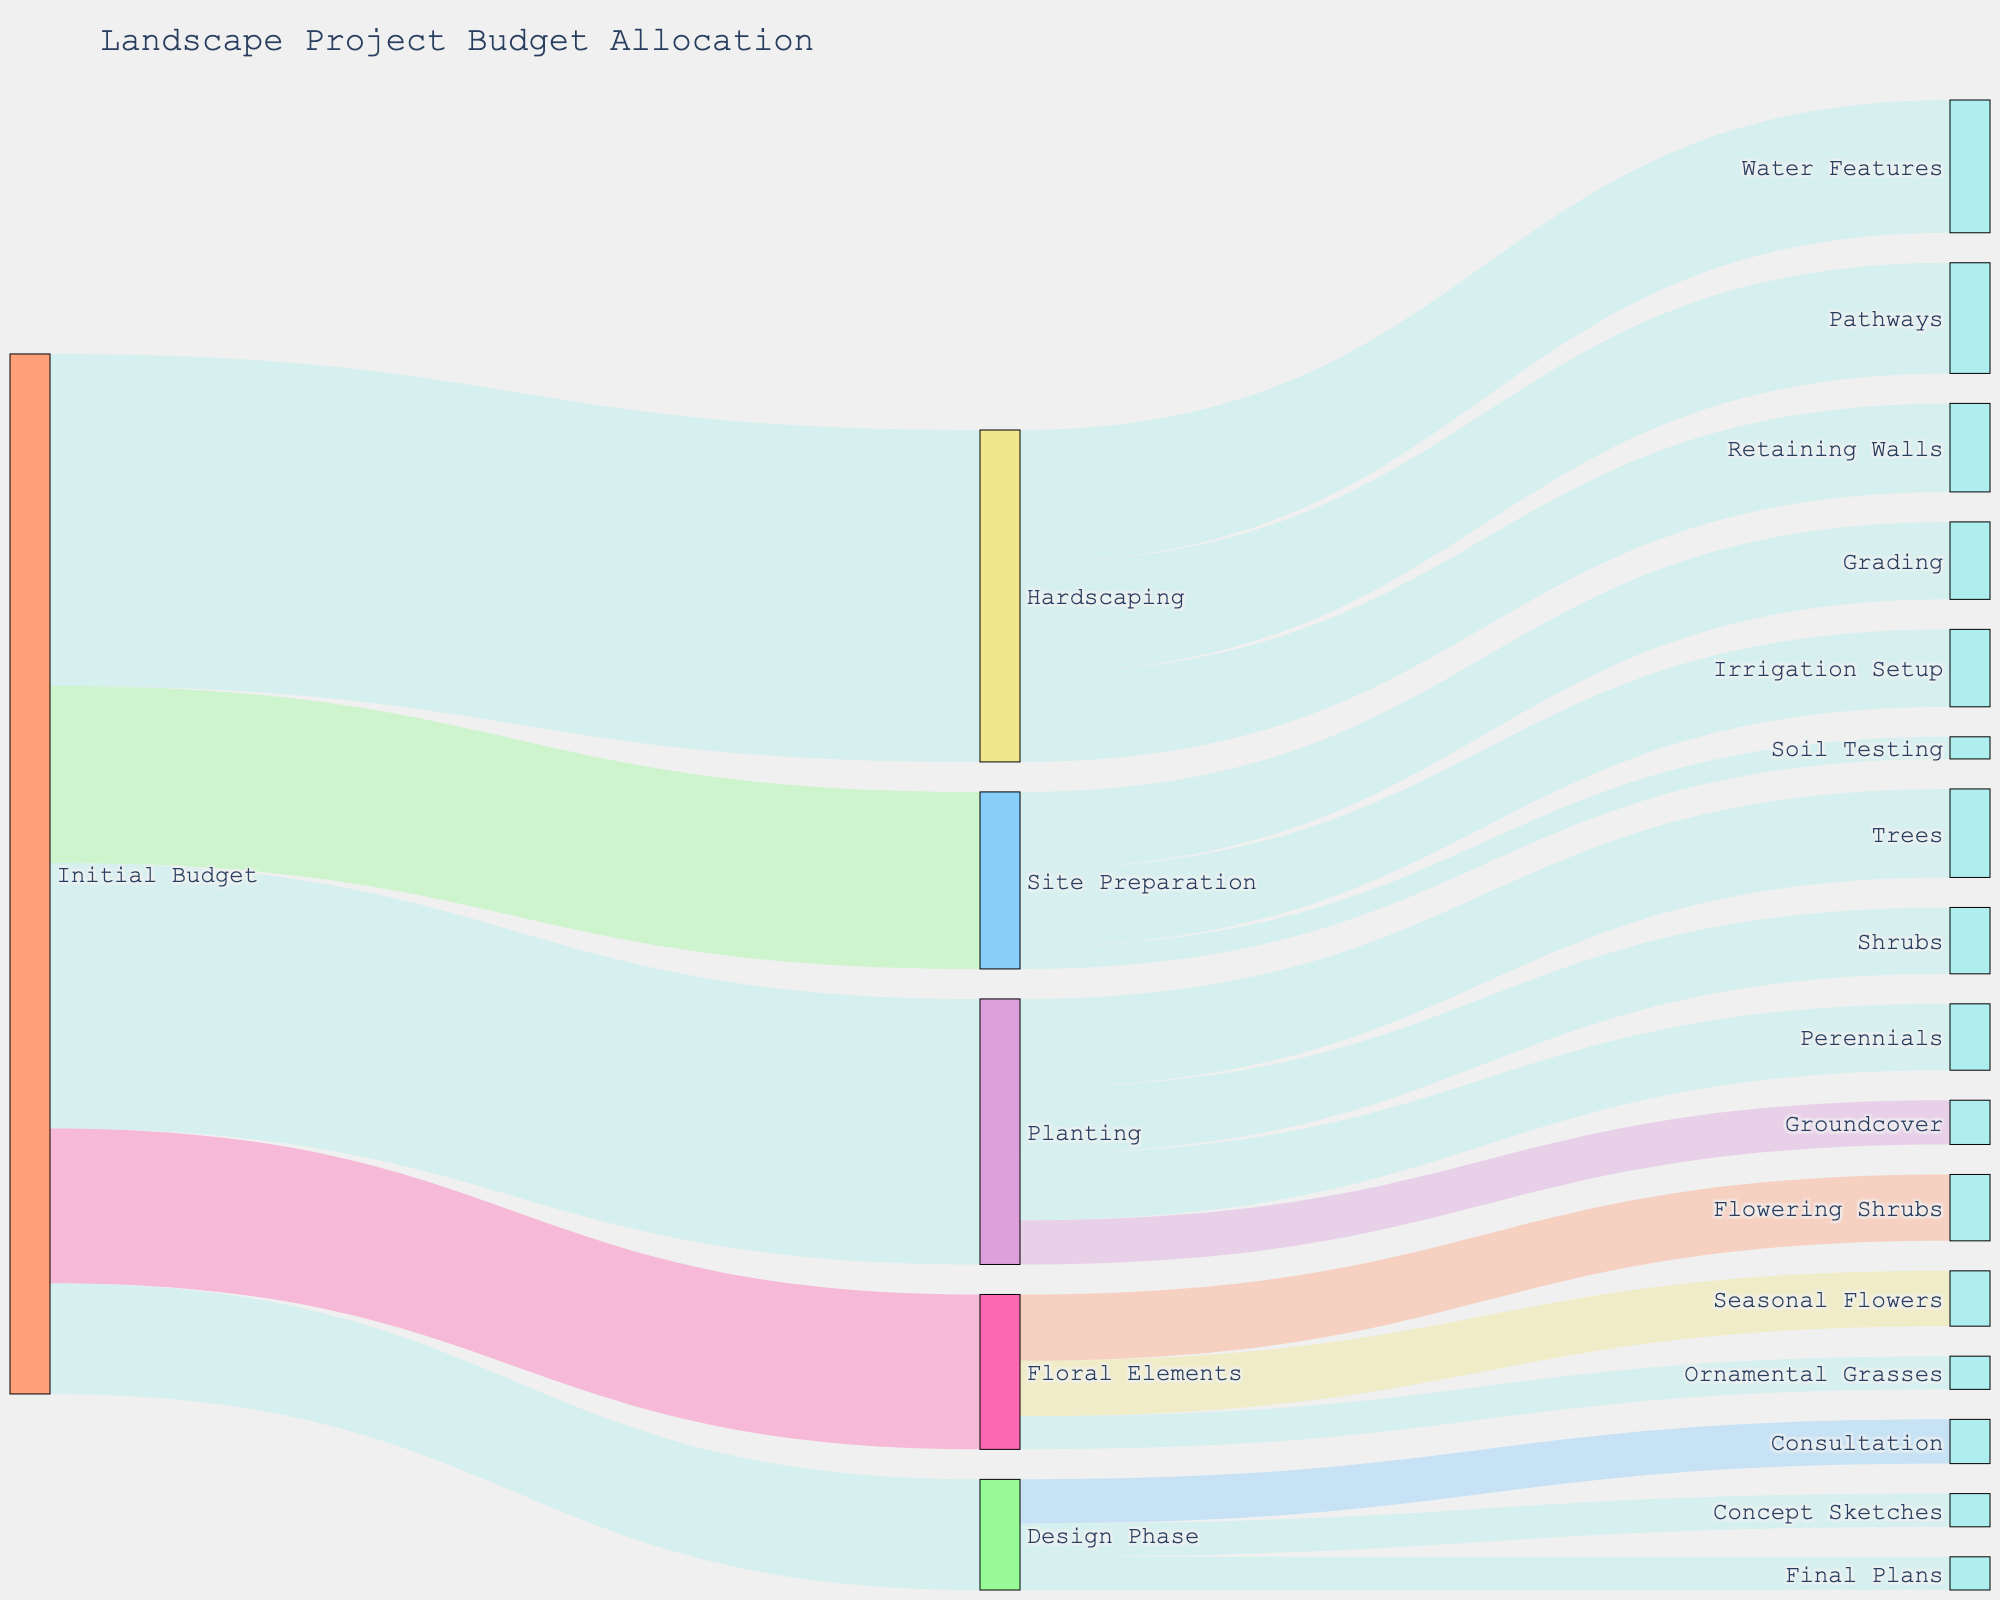what is the main title of the figure? The main title can be found at the top of the figure. It indicates the subject of the visualization.
Answer: Landscape Project Budget Allocation which phase has the highest initial budget allocation? By examining the size of the budget allocations starting from "Initial Budget", the "Hardscaping" phase appears to have the thickest flow, indicating the highest budget.
Answer: Hardscaping how much of the initial budget is allocated to floral elements? Follow the flow from "Initial Budget" to "Floral Elements", where it shows an allocation of 7000.
Answer: 7000 what are the sub-components of the design phase? Trace the flow from "Design Phase" to its three sub-components: "Consultation", "Concept Sketches", and "Final Plans."
Answer: Consultation, Concept Sketches, Final Plans compare the budget allocated to trees with the budget for water features Trace the flow from "Planting" to "Trees" and from "Hardscaping" to "Water Features" to see that trees get 4000 and water features get 6000. The budget for water features is higher.
Answer: Water features have a higher budget than trees what is the sum of the budgets for site preparation and planting? Follow the flows from "Initial Budget" to "Site Preparation" (8000) and "Planting" (12000), then add these values. 8000 + 12000 = 20000.
Answer: 20000 which sub-component of floral elements has the smallest budget allocation? By comparing the flows from "Floral Elements" to its sub-components, "Ornamental Grasses" with 1500 is the smallest allocation.
Answer: Ornamental Grasses how does the allocation to soil testing compare to irrigation setup in the site preparation phase? Trace the budget allocation from "Site Preparation" to "Soil Testing" (1000) and to "Irrigation Setup" (3500). Irrigation setup has a larger allocation.
Answer: Irrigation setup has a larger allocation what is the total budget allocated to consultation and final plans in the design phase? From "Design Phase", add the budgets for "Consultation" (2000) and "Final Plans" (1500). 2000 + 1500 = 3500.
Answer: 3500 which phase has the lowest allocation from the initial budget? Compare all flows from "Initial Budget". The "Design Phase" with 5000 has the smallest allocation.
Answer: Design Phase 